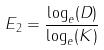Convert formula to latex. <formula><loc_0><loc_0><loc_500><loc_500>E _ { 2 } = \frac { \log _ { e } ( D ) } { \log _ { e } ( K ) }</formula> 